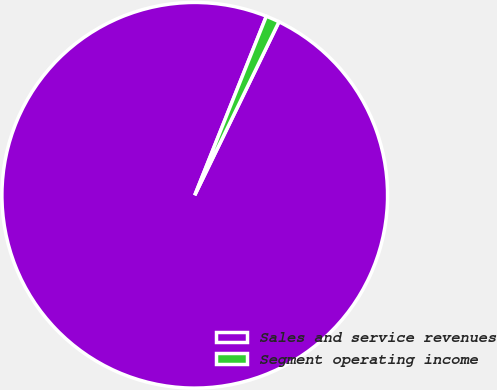Convert chart. <chart><loc_0><loc_0><loc_500><loc_500><pie_chart><fcel>Sales and service revenues<fcel>Segment operating income<nl><fcel>98.86%<fcel>1.14%<nl></chart> 